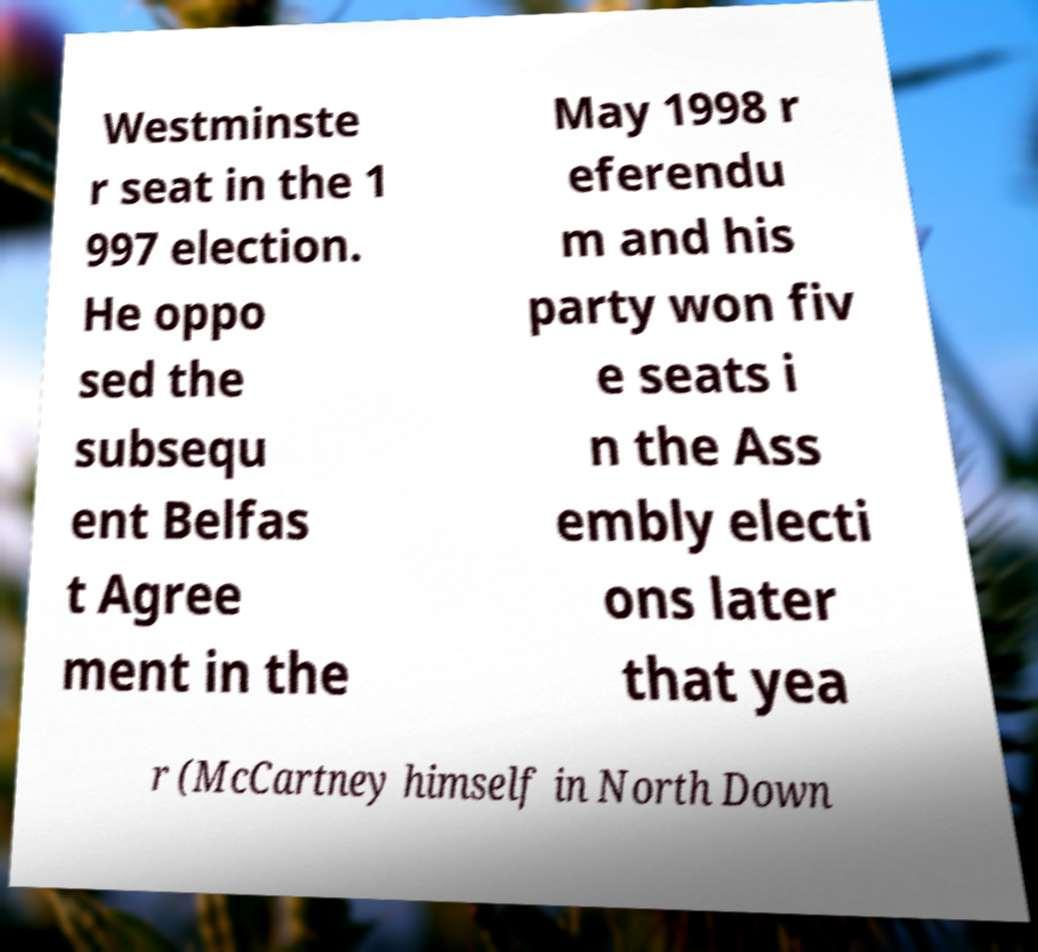Could you assist in decoding the text presented in this image and type it out clearly? Westminste r seat in the 1 997 election. He oppo sed the subsequ ent Belfas t Agree ment in the May 1998 r eferendu m and his party won fiv e seats i n the Ass embly electi ons later that yea r (McCartney himself in North Down 